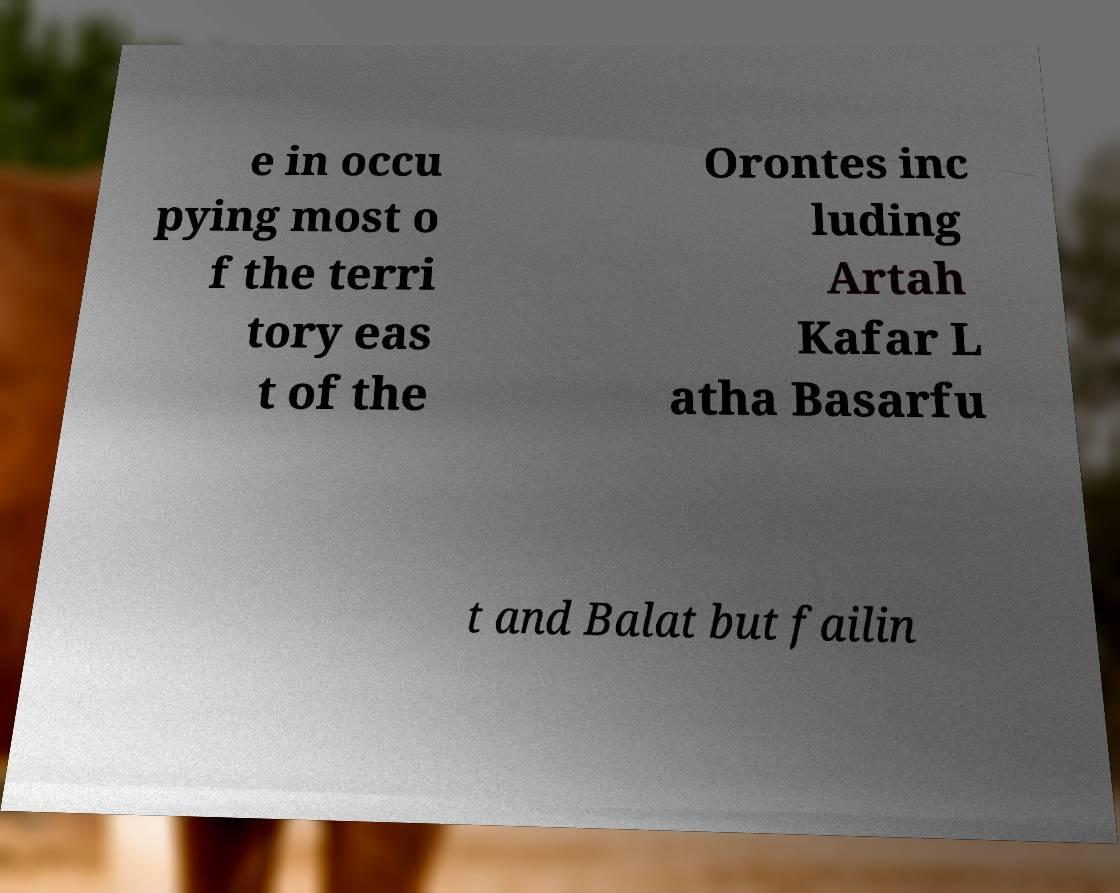What messages or text are displayed in this image? I need them in a readable, typed format. e in occu pying most o f the terri tory eas t of the Orontes inc luding Artah Kafar L atha Basarfu t and Balat but failin 